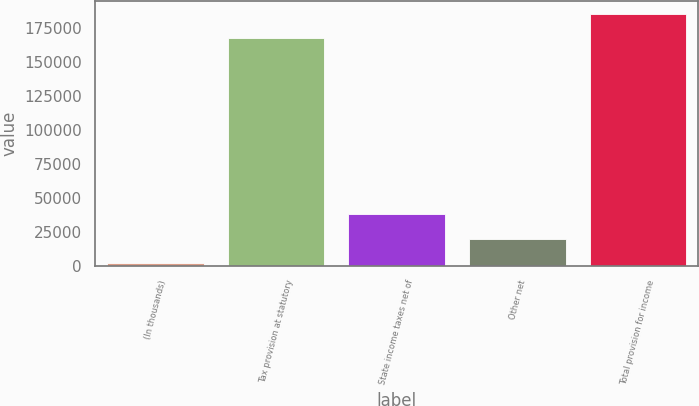Convert chart to OTSL. <chart><loc_0><loc_0><loc_500><loc_500><bar_chart><fcel>(In thousands)<fcel>Tax provision at statutory<fcel>State income taxes net of<fcel>Other net<fcel>Total provision for income<nl><fcel>2016<fcel>167156<fcel>37977.2<fcel>19996.6<fcel>185137<nl></chart> 